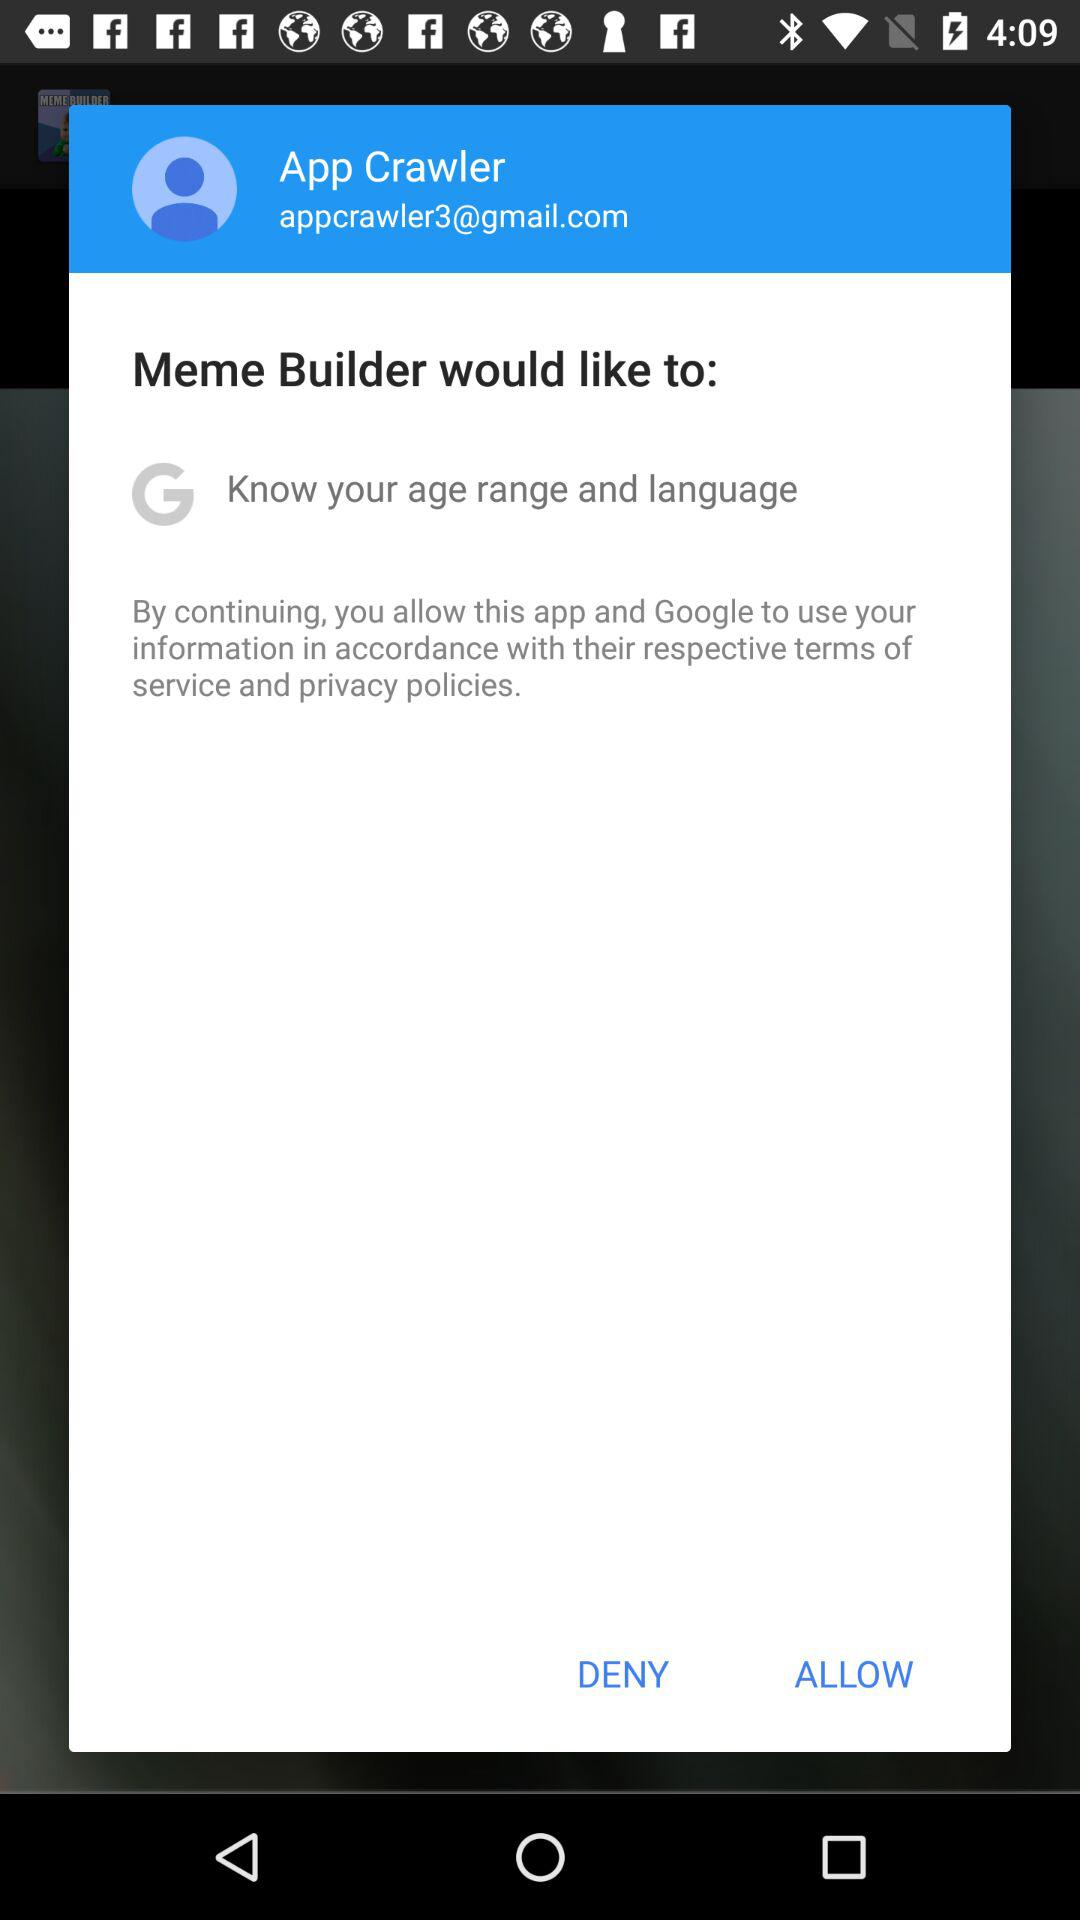What Gmail address is used? The used Gmail address is appcrawler3@gmail.com. 